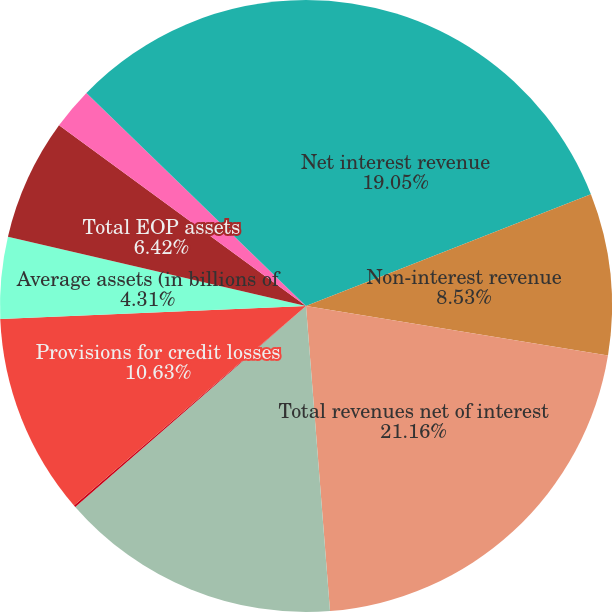Convert chart. <chart><loc_0><loc_0><loc_500><loc_500><pie_chart><fcel>Net interest revenue<fcel>Non-interest revenue<fcel>Total revenues net of interest<fcel>Total operating expenses<fcel>Provision for benefits and<fcel>Provisions for credit losses<fcel>Average assets (in billions of<fcel>Total EOP assets<fcel>Average deposits (in billions<fcel>Retail banking<nl><fcel>19.06%<fcel>8.53%<fcel>21.17%<fcel>14.85%<fcel>0.1%<fcel>10.63%<fcel>4.31%<fcel>6.42%<fcel>2.21%<fcel>12.74%<nl></chart> 